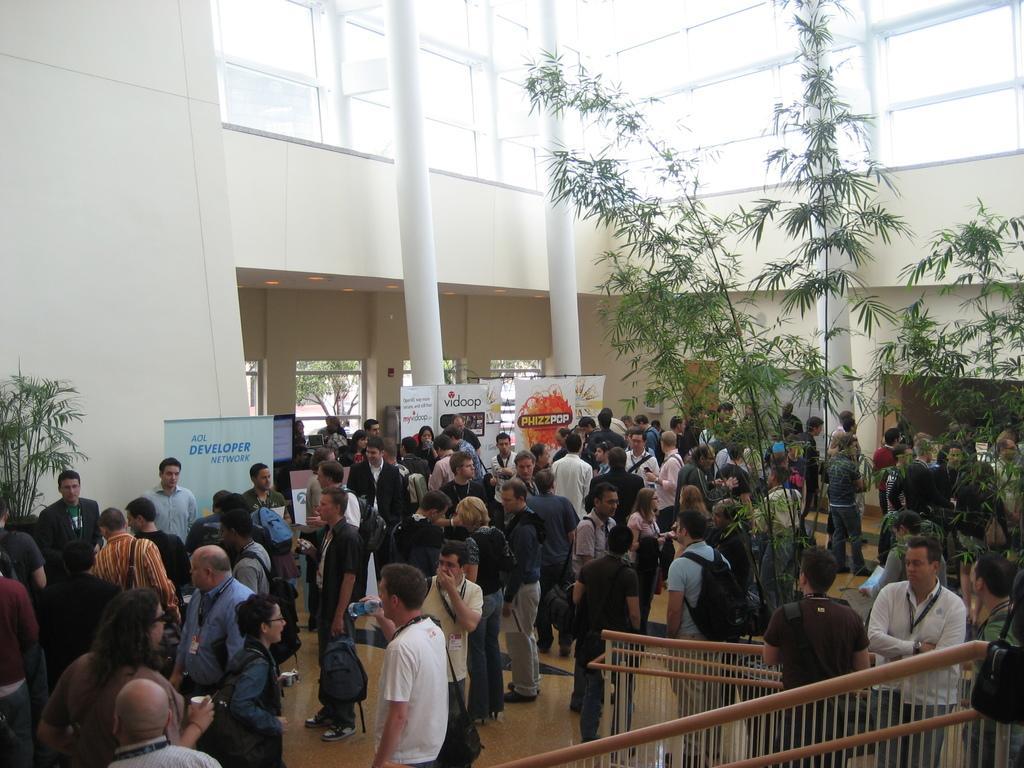Describe this image in one or two sentences. It looks like some event inside a building,there are a lot of people gathered on the floor and behind the crowd there are different banners. 